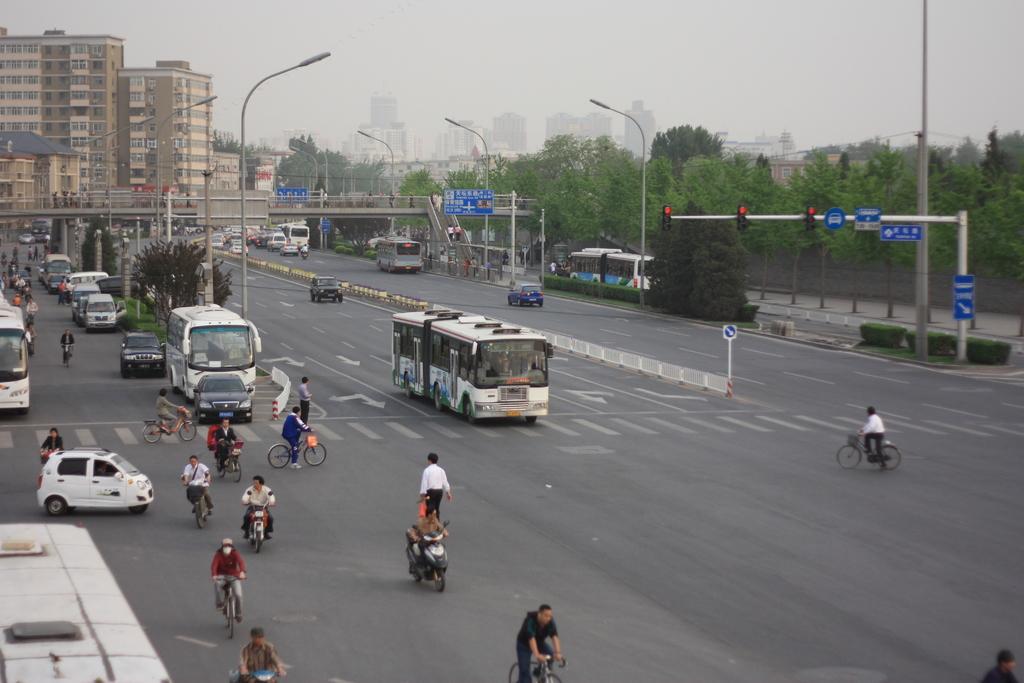Describe this image in one or two sentences. There are roads. On the road there are buses and vehicles. Many people are riding scooters and cycles. There are light poles. Also there are sign boards and traffic lights. In the back there are trees, sky and buildings. 